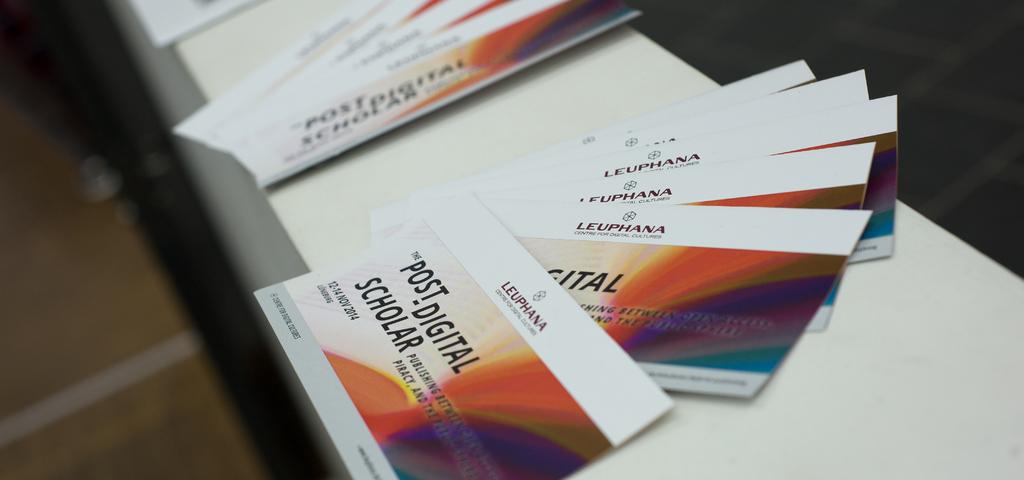What are on the cards?
Ensure brevity in your answer.  Post digital scholar. What color is the text?
Provide a succinct answer. Answering does not require reading text in the image. 